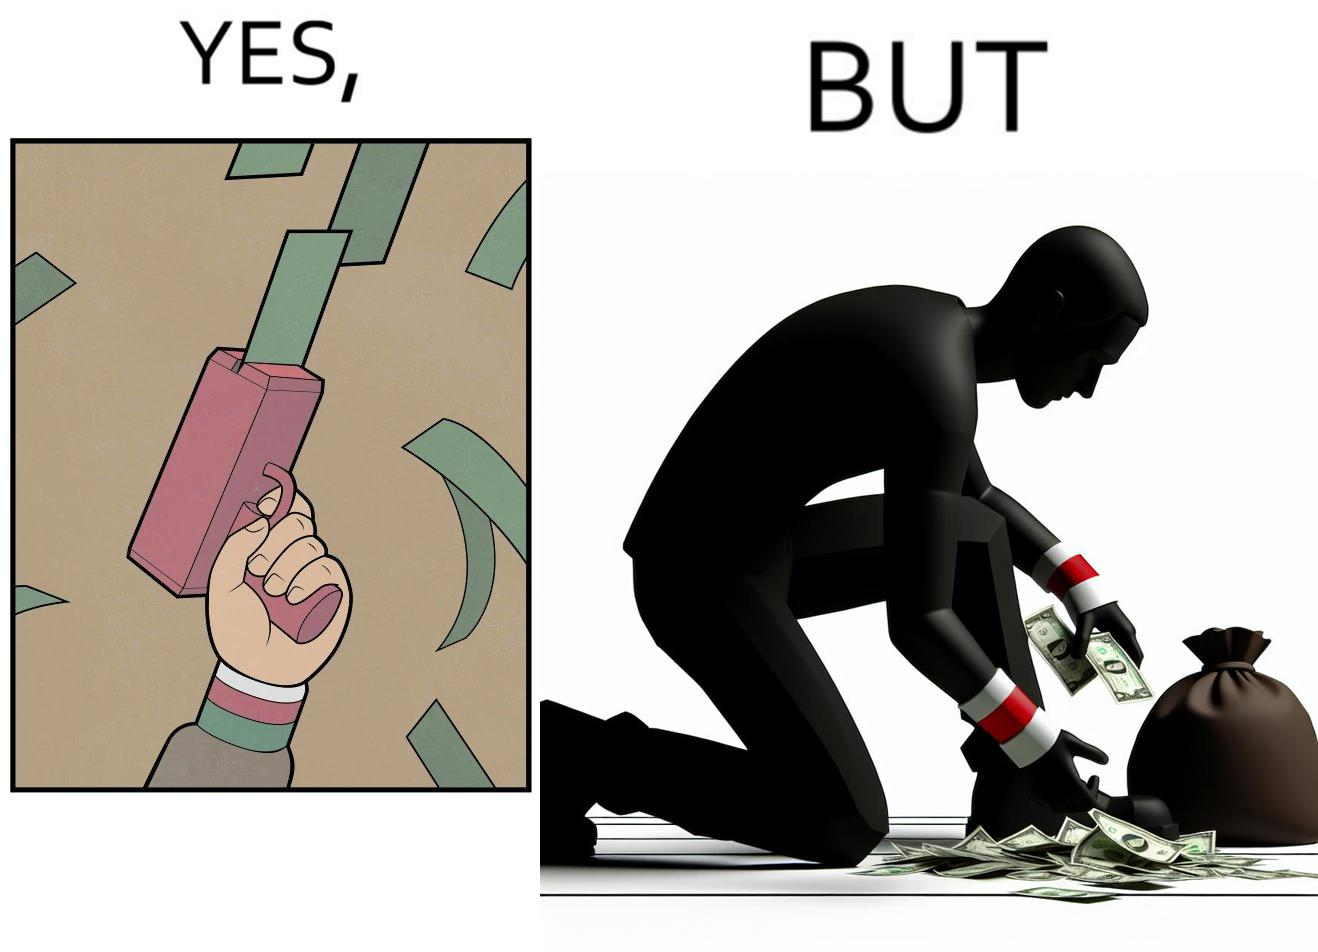What does this image depict? The image is satirical because the man that is shooting money in the air causing a rain of money bills is the same person who is crouching down to collect the fallen dollar bills from the ground which makes the act of shooting bills in the air not so fun. 